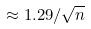<formula> <loc_0><loc_0><loc_500><loc_500>\approx 1 . 2 9 / \sqrt { n }</formula> 